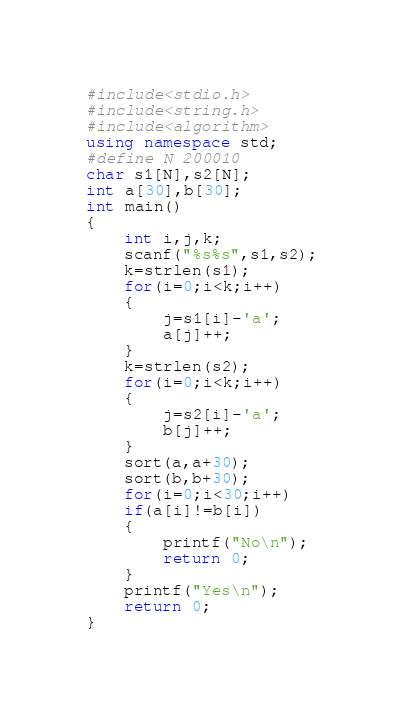<code> <loc_0><loc_0><loc_500><loc_500><_C++_>#include<stdio.h>
#include<string.h>
#include<algorithm>
using namespace std;
#define N 200010
char s1[N],s2[N];
int a[30],b[30];
int main()
{
    int i,j,k;
    scanf("%s%s",s1,s2);
    k=strlen(s1);
    for(i=0;i<k;i++)
    {
        j=s1[i]-'a';
        a[j]++;
    }
    k=strlen(s2);
    for(i=0;i<k;i++)
    {
        j=s2[i]-'a';
        b[j]++;
    }
    sort(a,a+30);
    sort(b,b+30);
    for(i=0;i<30;i++)
    if(a[i]!=b[i])
    {
        printf("No\n");
        return 0;
    }
    printf("Yes\n");
    return 0;
}</code> 